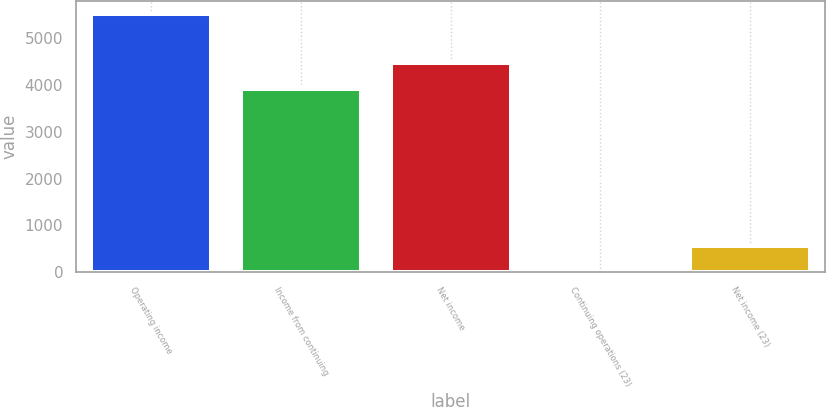<chart> <loc_0><loc_0><loc_500><loc_500><bar_chart><fcel>Operating income<fcel>Income from continuing<fcel>Net income<fcel>Continuing operations (23)<fcel>Net income (23)<nl><fcel>5520<fcel>3914<fcel>4465.68<fcel>3.23<fcel>554.91<nl></chart> 